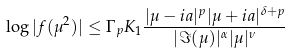<formula> <loc_0><loc_0><loc_500><loc_500>\log | f ( \mu ^ { 2 } ) | \leq \Gamma _ { p } K _ { 1 } \frac { | \mu - i a | ^ { p } | \mu + i a | ^ { \delta + p } } { | \Im ( \mu ) | ^ { \alpha } | \mu | ^ { \nu } }</formula> 